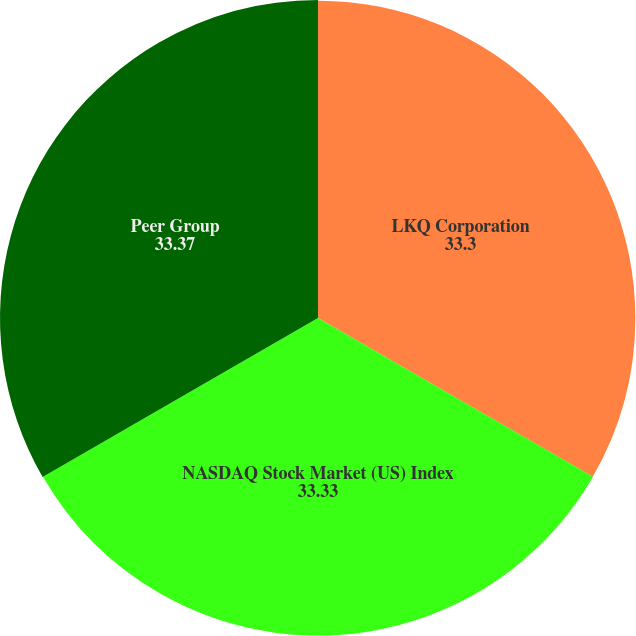Convert chart. <chart><loc_0><loc_0><loc_500><loc_500><pie_chart><fcel>LKQ Corporation<fcel>NASDAQ Stock Market (US) Index<fcel>Peer Group<nl><fcel>33.3%<fcel>33.33%<fcel>33.37%<nl></chart> 